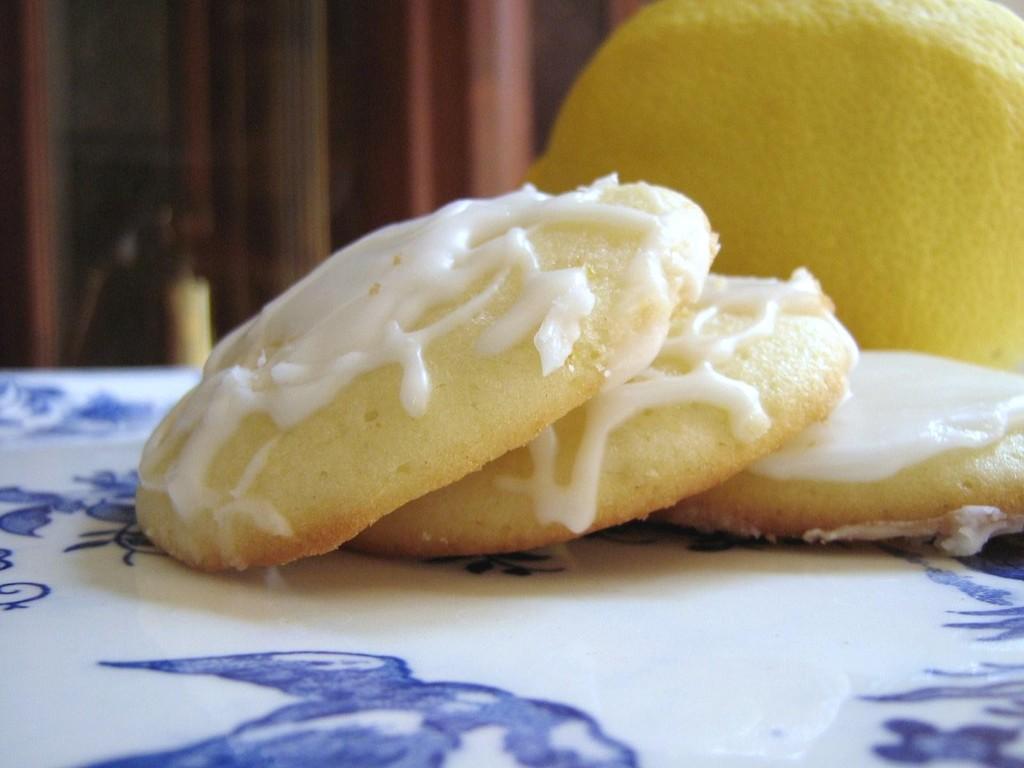In one or two sentences, can you explain what this image depicts? This image consists of cookies along with cream are kept in a plate. To the right, it looks like an orange. In the background there are curtains in brown color. 